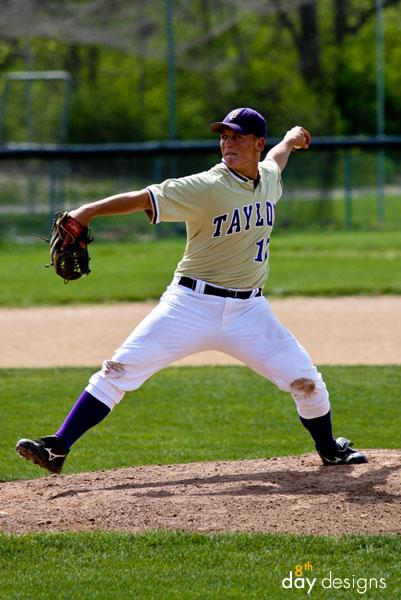Which hand is his dominant hand?
Keep it brief. Left. In what direction will the ball travel when the pitcher releases the ball?
Concise answer only. Left. Is he a baseball player?
Be succinct. Yes. Which hand is holding the ball?
Give a very brief answer. Left. 